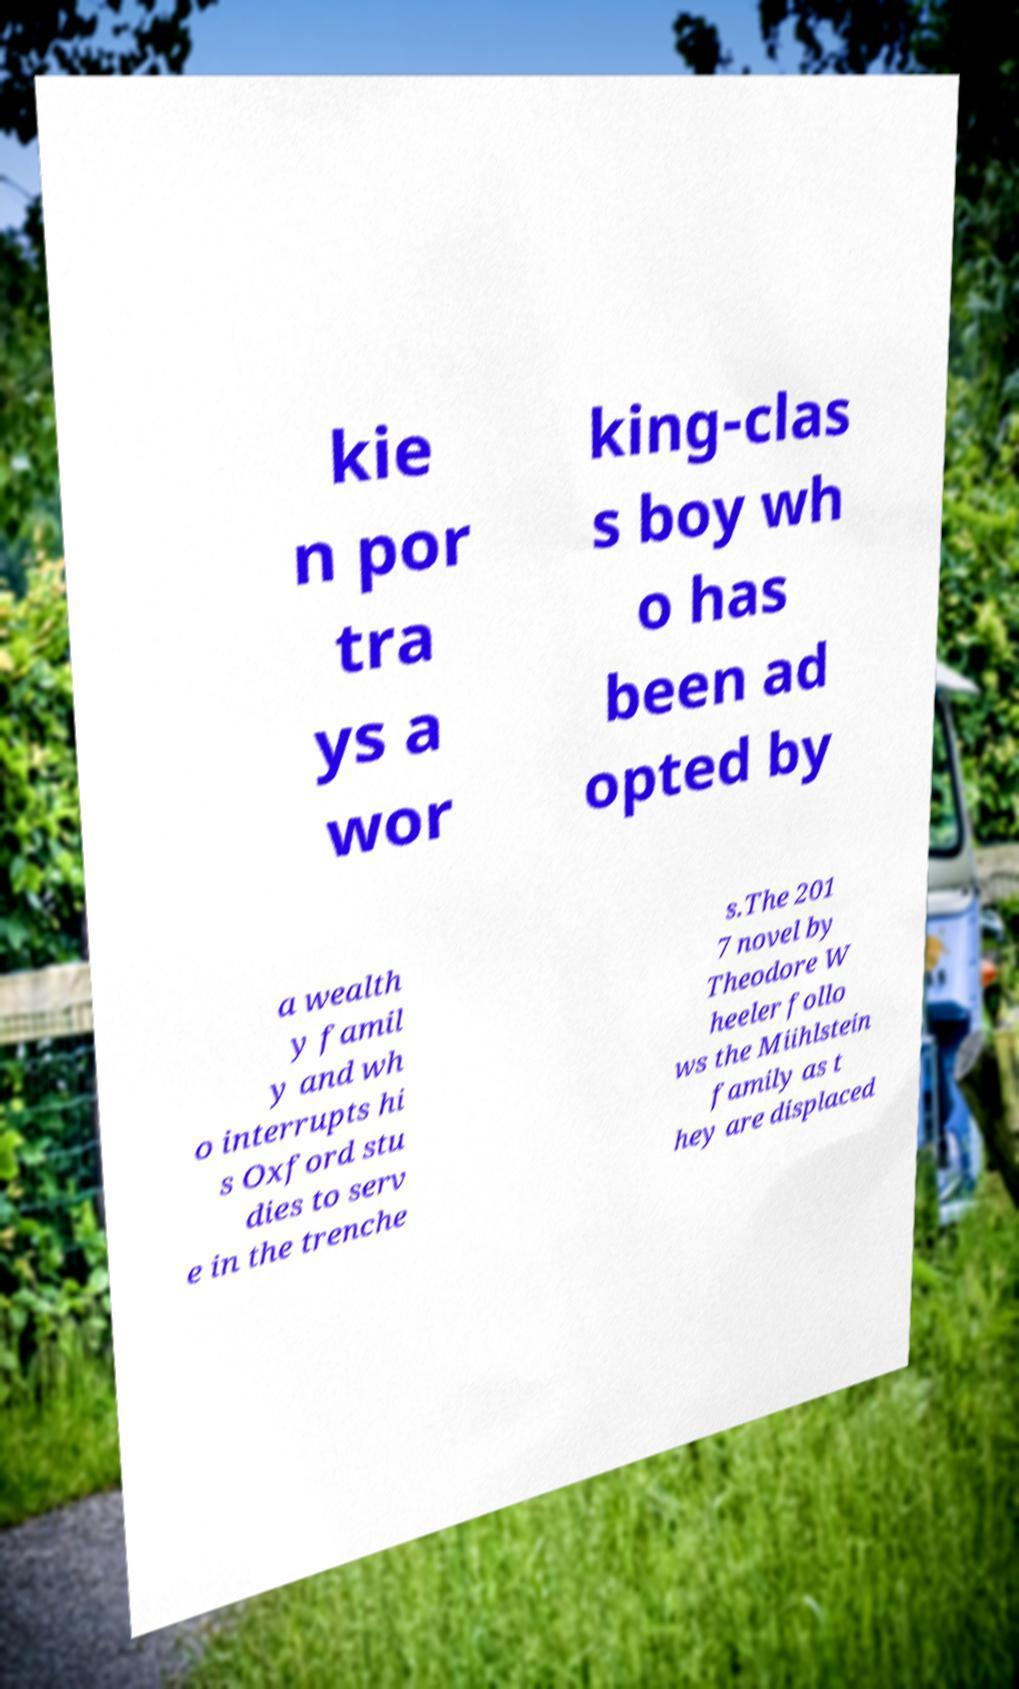Could you assist in decoding the text presented in this image and type it out clearly? kie n por tra ys a wor king-clas s boy wh o has been ad opted by a wealth y famil y and wh o interrupts hi s Oxford stu dies to serv e in the trenche s.The 201 7 novel by Theodore W heeler follo ws the Miihlstein family as t hey are displaced 